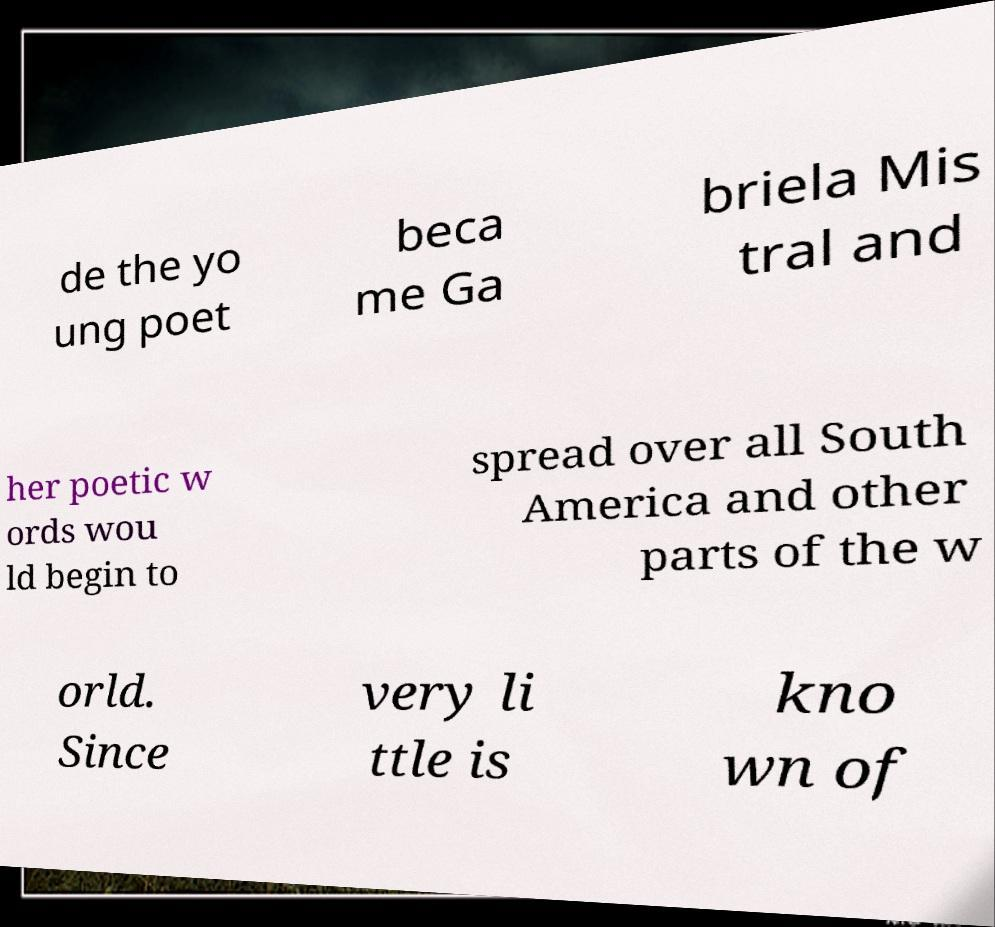Could you assist in decoding the text presented in this image and type it out clearly? de the yo ung poet beca me Ga briela Mis tral and her poetic w ords wou ld begin to spread over all South America and other parts of the w orld. Since very li ttle is kno wn of 